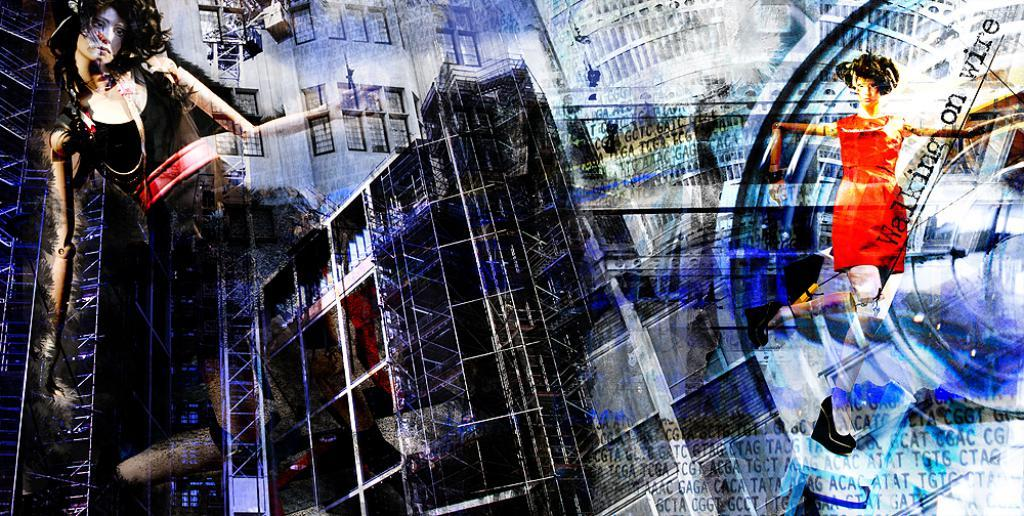What can be observed about the image's appearance? The image is edited. What subjects are depicted in the image? There are depictions of girls in the image. What advice is the fish giving to the girls in the image? There is no fish present in the image, so it cannot provide any advice. 